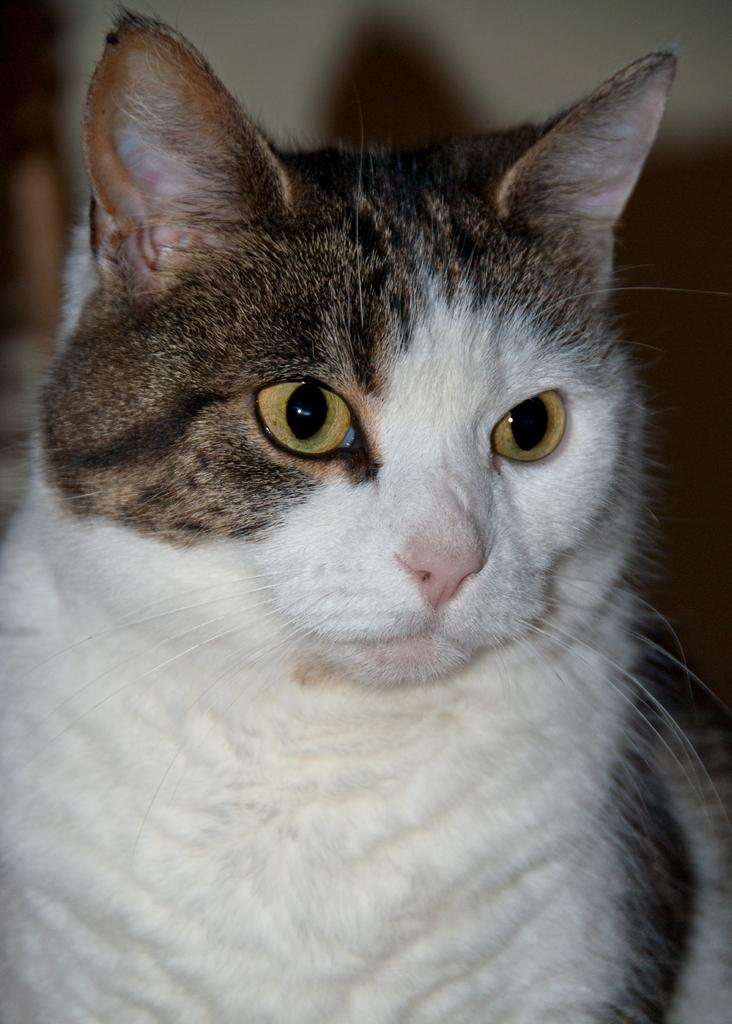What type of animal is in the image? There is a cat in the image. Where is the cat located in the image? The cat is towards the bottom of the image. What can be seen in the background of the image? There is a wall in the background of the image. What type of cannon is present in the image? There is no cannon present in the image; it features a cat and a wall in the background. How many boots can be seen in the image? There are no boots present in the image. 